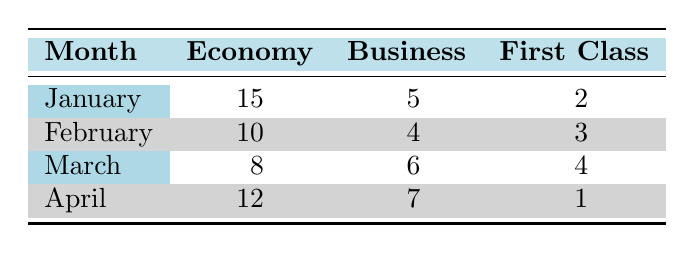What is the cancellation count for Economy class in January? The table shows the cancellation count for Economy class in January as 15.
Answer: 15 What was the total number of cancellations for First Class across all months? To find the total cancellations for First Class, we add the values from each month: 2 (January) + 3 (February) + 4 (March) + 1 (April) = 10.
Answer: 10 Was there a cancellation due to Operational Disruption in Economy class? Referring to the table, Operational Disruption is recorded only under First Class, so there is no cancellation for Economy class in this category.
Answer: No Which flight class had the highest number of cancellations in March? The table indicates that Economy class had 8 cancellations, Business class had 6, and First Class had 4. Thus, the highest is Economy class with 8 cancellations.
Answer: Economy What is the average cancellation count for Business class across the months displayed? To calculate the average for Business class, we sum the counts: 5 (January) + 4 (February) + 6 (March) + 7 (April) = 22. There are 4 months, so the average is 22/4 = 5.5.
Answer: 5.5 Is the reason for cancellations in January exclusively related to weather conditions? The table lists three different reasons for cancellations in January: Weather Conditions, Travel Restrictions, and Personal Reasons. Thus, the answer is no.
Answer: No What was the cancellation reason for First Class in February? According to the table, the reason for First Class cancellations in February was due to Weather Conditions, as indicated in the relevant entry.
Answer: Weather Conditions How many cancellations were related to Mechanical Issues across all classes? By reviewing the table, Mechanical Issues were only recorded in February under Economy class with a count of 10. Therefore, there were no other cancellations related to this issue.
Answer: 10 